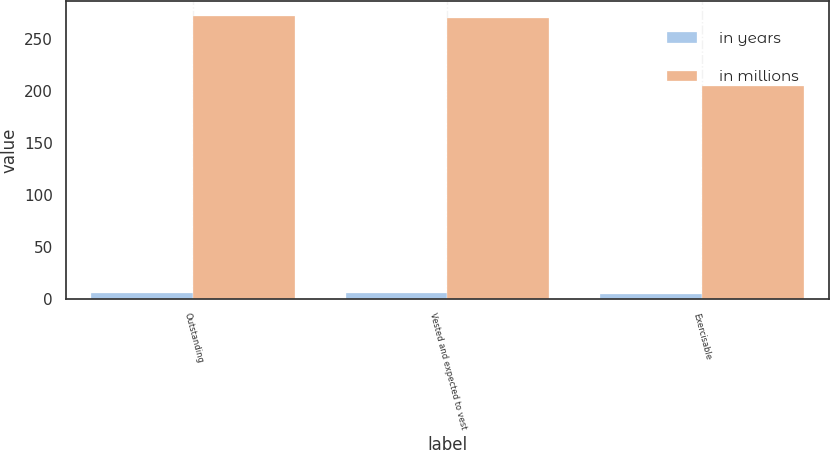Convert chart. <chart><loc_0><loc_0><loc_500><loc_500><stacked_bar_chart><ecel><fcel>Outstanding<fcel>Vested and expected to vest<fcel>Exercisable<nl><fcel>in years<fcel>5.64<fcel>5.62<fcel>4.5<nl><fcel>in millions<fcel>273<fcel>271<fcel>205<nl></chart> 